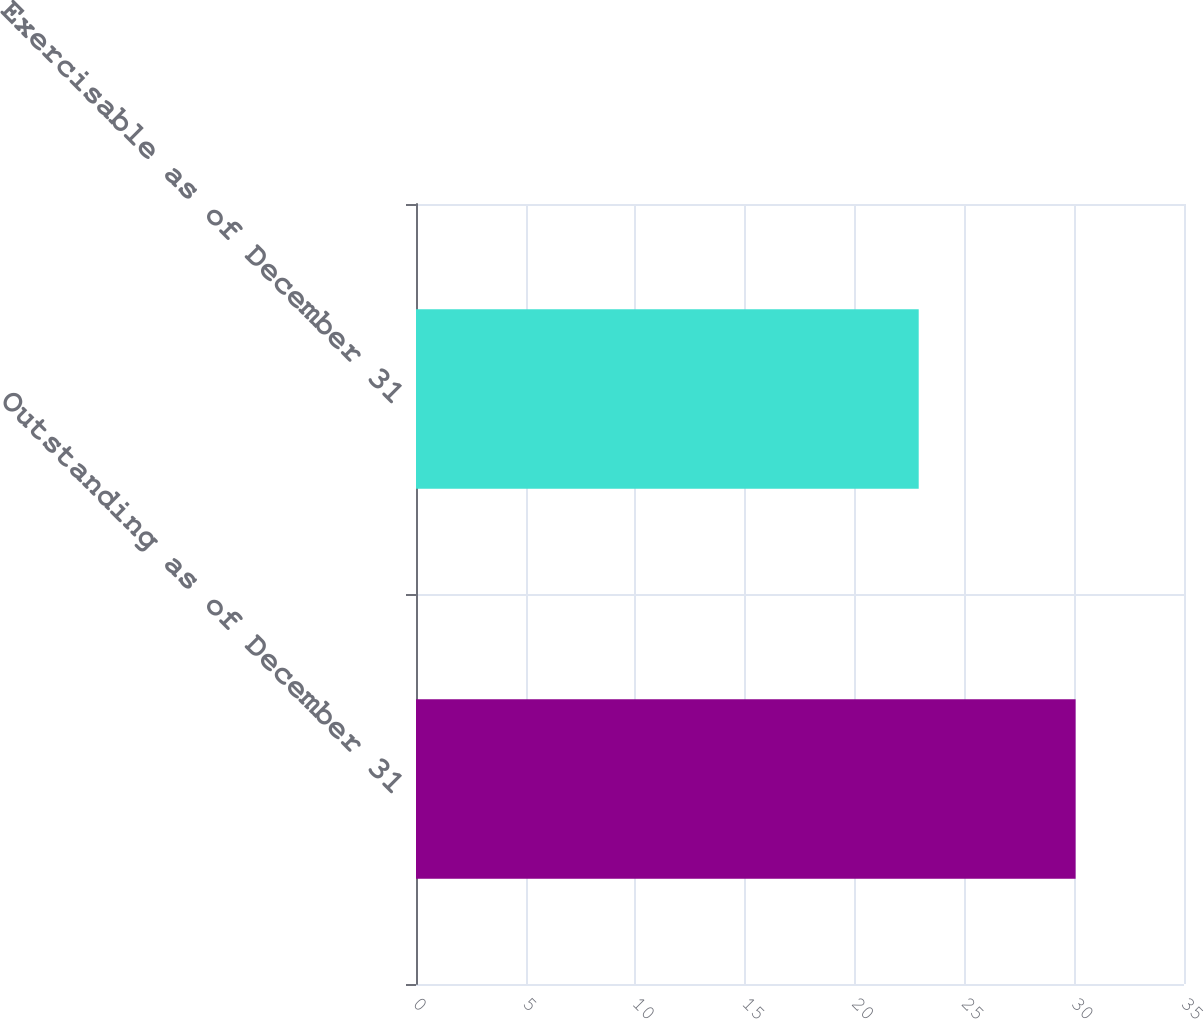Convert chart to OTSL. <chart><loc_0><loc_0><loc_500><loc_500><bar_chart><fcel>Outstanding as of December 31<fcel>Exercisable as of December 31<nl><fcel>30.06<fcel>22.91<nl></chart> 